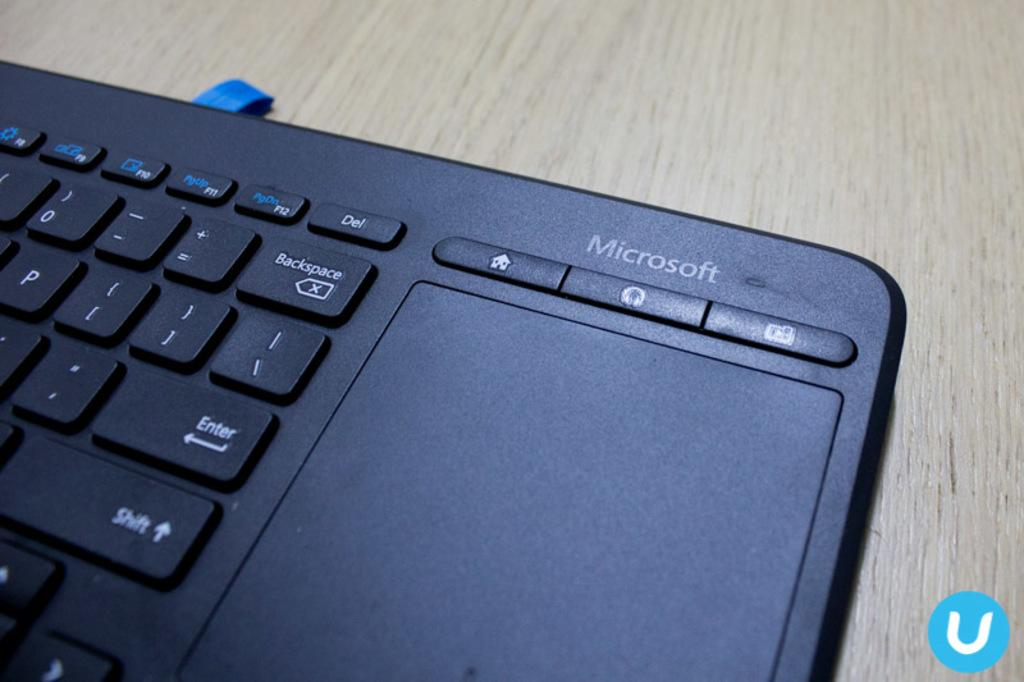<image>
Offer a succinct explanation of the picture presented. a laptop computer that has the word, microsoft, on it 